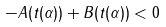<formula> <loc_0><loc_0><loc_500><loc_500>- A ( t ( \alpha ) ) + B ( t ( \alpha ) ) < 0</formula> 